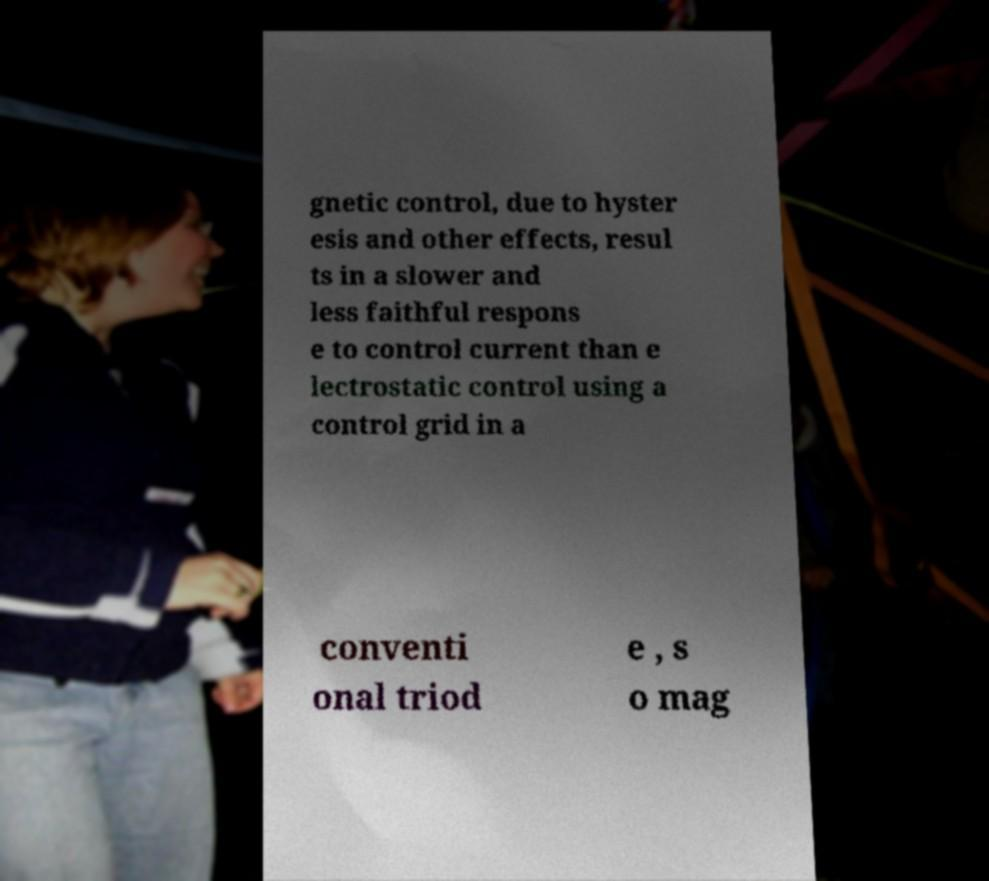Can you read and provide the text displayed in the image?This photo seems to have some interesting text. Can you extract and type it out for me? gnetic control, due to hyster esis and other effects, resul ts in a slower and less faithful respons e to control current than e lectrostatic control using a control grid in a conventi onal triod e , s o mag 